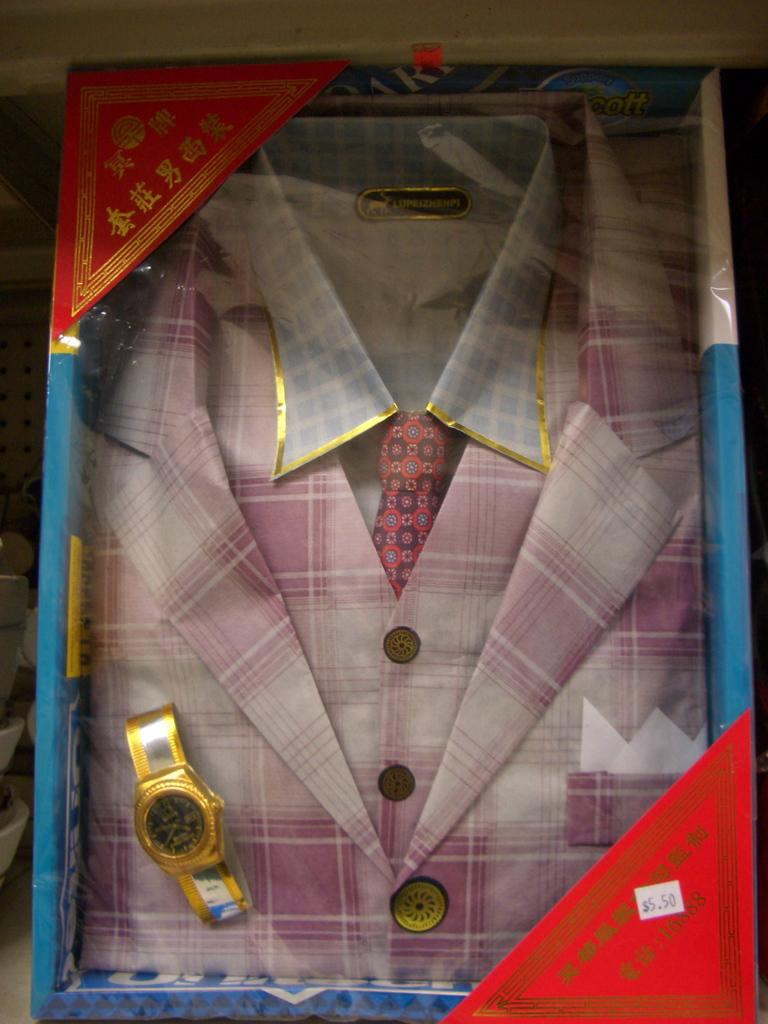<image>
Summarize the visual content of the image. a suit is priced at 5.50 with a watch 